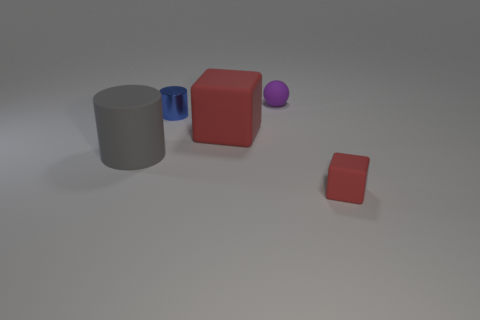Subtract all gray cylinders. How many cylinders are left? 1 Add 2 purple matte balls. How many objects exist? 7 Subtract all cylinders. How many objects are left? 3 Add 5 small spheres. How many small spheres are left? 6 Add 1 cyan rubber balls. How many cyan rubber balls exist? 1 Subtract 0 yellow cubes. How many objects are left? 5 Subtract 2 cylinders. How many cylinders are left? 0 Subtract all yellow spheres. Subtract all blue blocks. How many spheres are left? 1 Subtract all blue cylinders. Subtract all large rubber things. How many objects are left? 2 